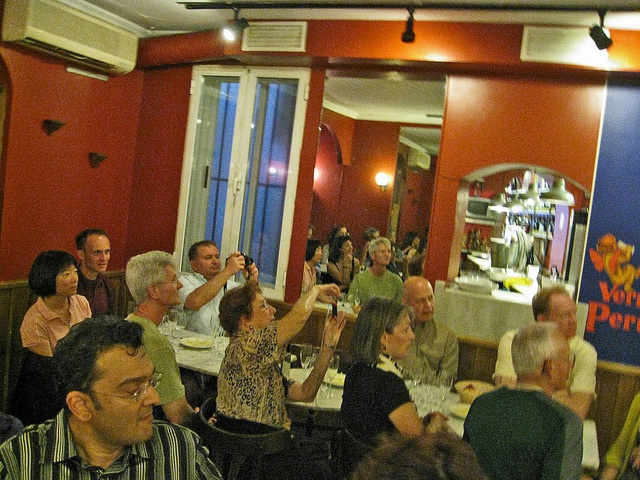Describe the objects in this image and their specific colors. I can see people in black, olive, and gray tones, people in black and olive tones, people in black and olive tones, people in black, olive, and maroon tones, and people in black, tan, and olive tones in this image. 